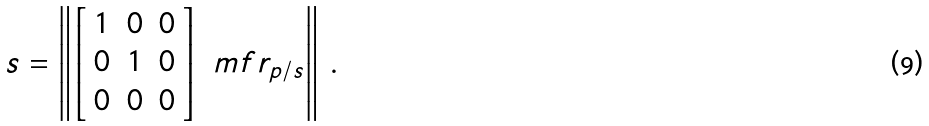<formula> <loc_0><loc_0><loc_500><loc_500>s = \left \| \left [ \begin{array} { c c c } 1 & 0 & 0 \\ 0 & 1 & 0 \\ 0 & 0 & 0 \end{array} \right ] \ m f r _ { p / s } \right \| \, .</formula> 